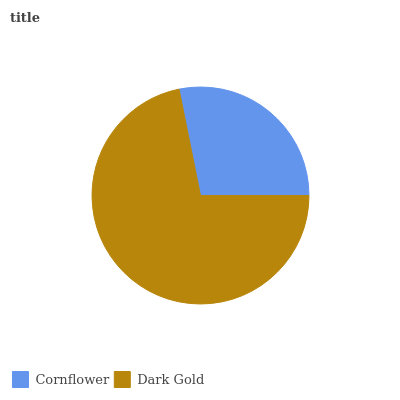Is Cornflower the minimum?
Answer yes or no. Yes. Is Dark Gold the maximum?
Answer yes or no. Yes. Is Dark Gold the minimum?
Answer yes or no. No. Is Dark Gold greater than Cornflower?
Answer yes or no. Yes. Is Cornflower less than Dark Gold?
Answer yes or no. Yes. Is Cornflower greater than Dark Gold?
Answer yes or no. No. Is Dark Gold less than Cornflower?
Answer yes or no. No. Is Dark Gold the high median?
Answer yes or no. Yes. Is Cornflower the low median?
Answer yes or no. Yes. Is Cornflower the high median?
Answer yes or no. No. Is Dark Gold the low median?
Answer yes or no. No. 